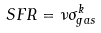Convert formula to latex. <formula><loc_0><loc_0><loc_500><loc_500>S F R = \nu \sigma _ { g a s } ^ { k }</formula> 